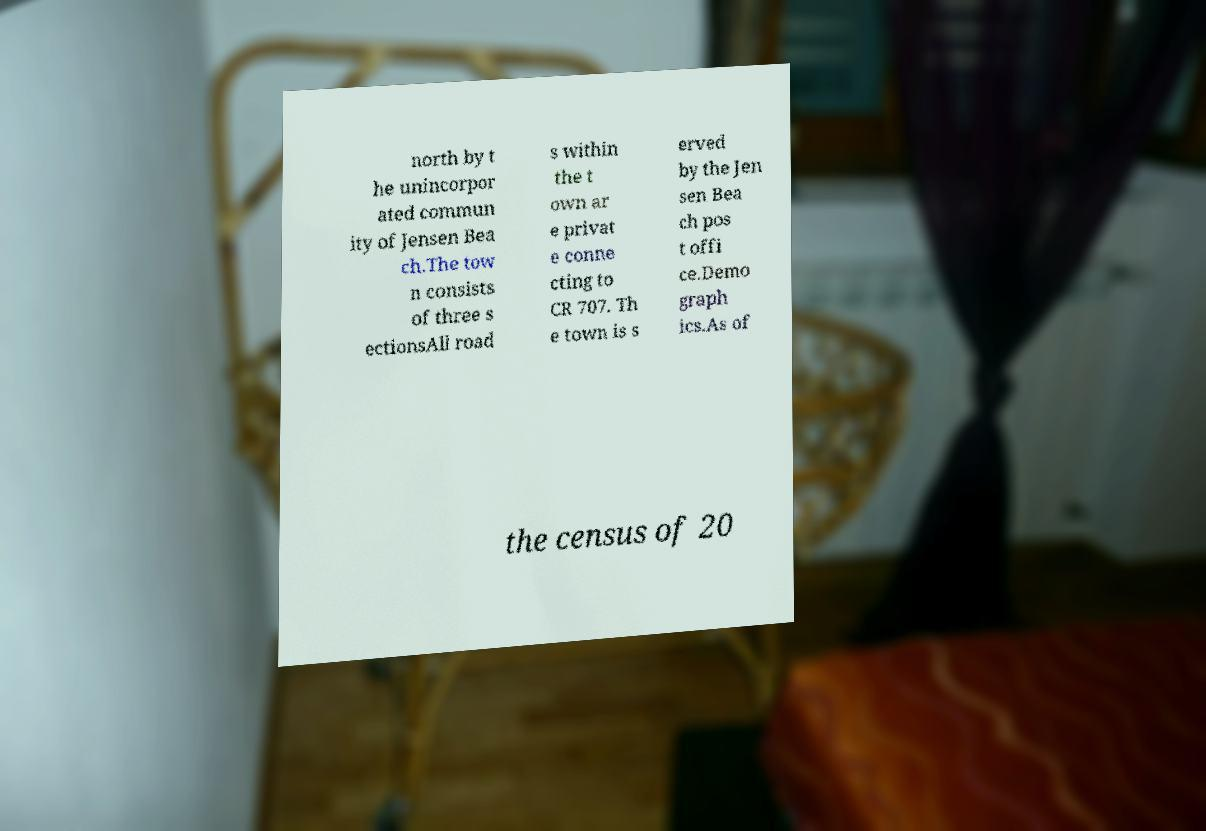Could you assist in decoding the text presented in this image and type it out clearly? north by t he unincorpor ated commun ity of Jensen Bea ch.The tow n consists of three s ectionsAll road s within the t own ar e privat e conne cting to CR 707. Th e town is s erved by the Jen sen Bea ch pos t offi ce.Demo graph ics.As of the census of 20 